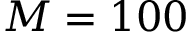<formula> <loc_0><loc_0><loc_500><loc_500>M = 1 0 0</formula> 